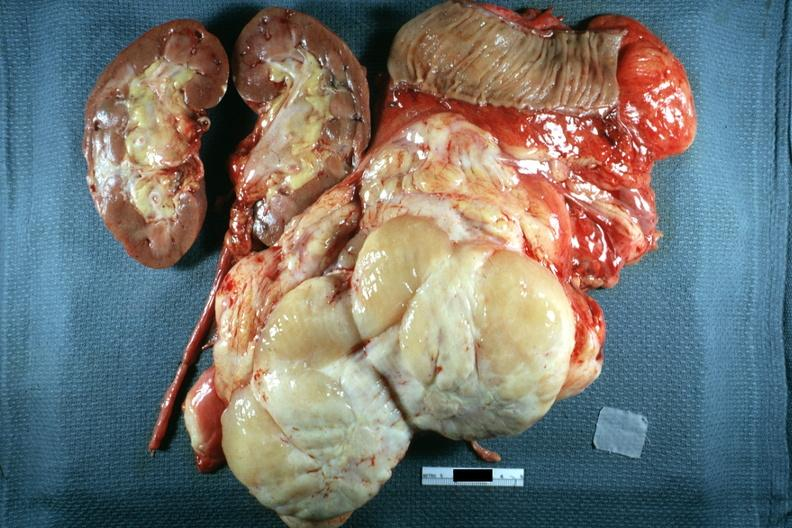s retroperitoneal liposarcoma present?
Answer the question using a single word or phrase. No 